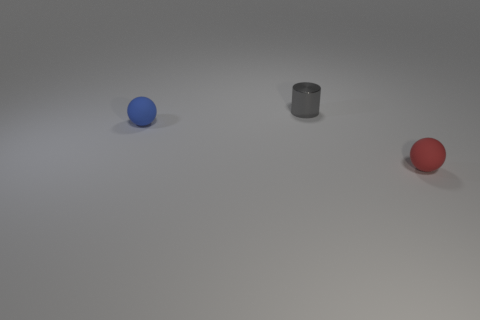Add 3 tiny cylinders. How many objects exist? 6 Subtract all red balls. How many balls are left? 1 Subtract 0 yellow cubes. How many objects are left? 3 Subtract all cylinders. How many objects are left? 2 Subtract all blue balls. Subtract all gray cylinders. How many balls are left? 1 Subtract all yellow rubber cylinders. Subtract all metal objects. How many objects are left? 2 Add 1 blue matte things. How many blue matte things are left? 2 Add 3 tiny gray matte objects. How many tiny gray matte objects exist? 3 